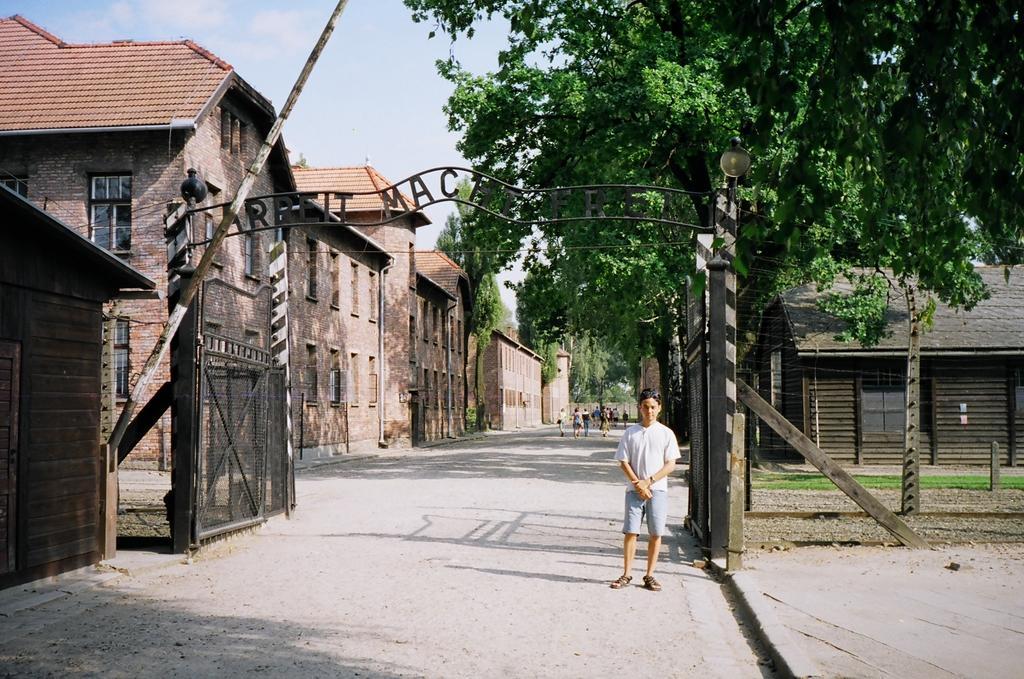Describe this image in one or two sentences. In the center of the image we can see one person is standing on the road. In the background, we can see the sky, clouds, trees, buildings, grass, few people and a few other objects. 